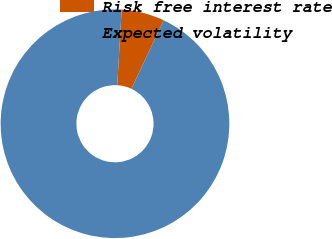<chart> <loc_0><loc_0><loc_500><loc_500><pie_chart><fcel>Risk free interest rate<fcel>Expected volatility<nl><fcel>6.07%<fcel>93.93%<nl></chart> 